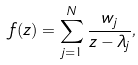Convert formula to latex. <formula><loc_0><loc_0><loc_500><loc_500>f ( z ) = \sum _ { j = 1 } ^ { N } \frac { w _ { j } } { z - \lambda _ { j } } ,</formula> 